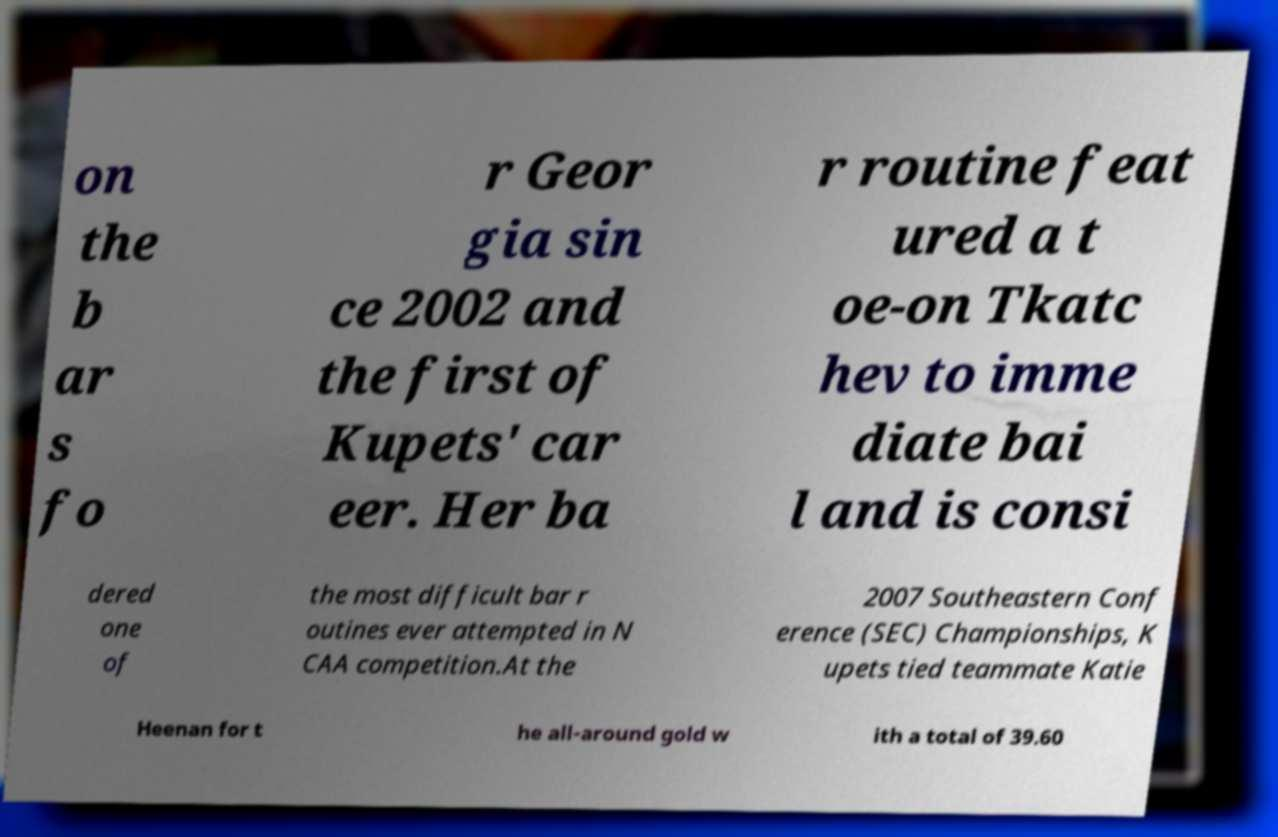Can you read and provide the text displayed in the image?This photo seems to have some interesting text. Can you extract and type it out for me? on the b ar s fo r Geor gia sin ce 2002 and the first of Kupets' car eer. Her ba r routine feat ured a t oe-on Tkatc hev to imme diate bai l and is consi dered one of the most difficult bar r outines ever attempted in N CAA competition.At the 2007 Southeastern Conf erence (SEC) Championships, K upets tied teammate Katie Heenan for t he all-around gold w ith a total of 39.60 